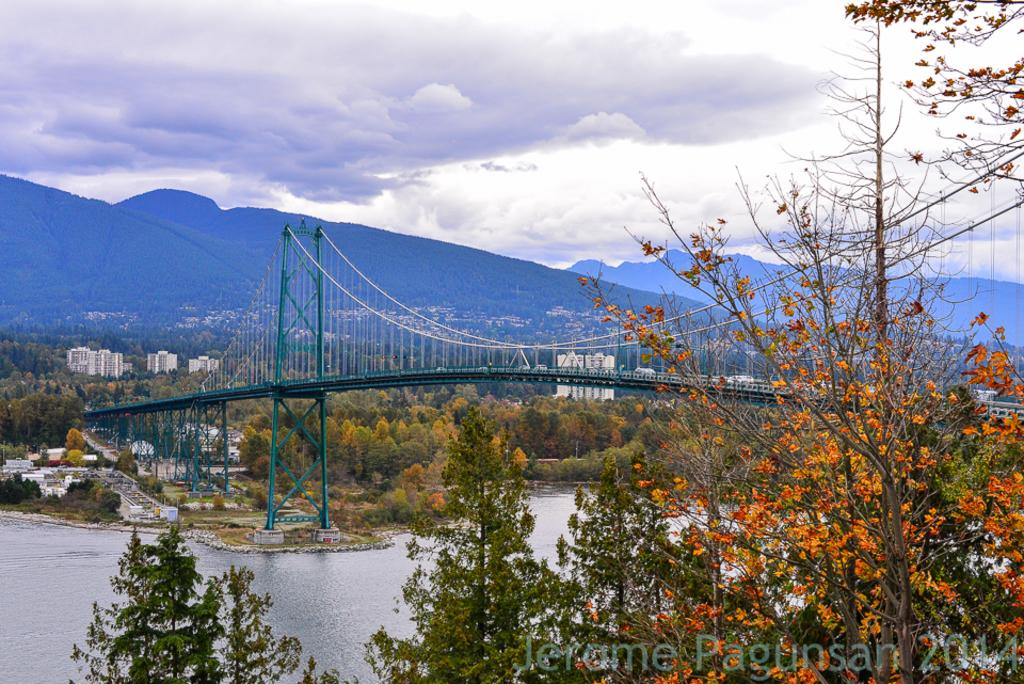What type of natural elements can be seen in the image? There are trees and water visible in the image. What type of man-made structures can be seen in the image? There are buildings and a bridge visible in the image. What type of terrain is present in the image? There are hills visible in the image. What part of the natural environment is visible in the image? The sky is visible in the image. What can be seen in the sky in the image? There are clouds visible in the image. Where is the cemetery located in the image? There is no cemetery present in the image. What time of day is it in the image, considering the presence of the frog? There is no frog present in the image, and therefore we cannot determine the time of day based on its presence. 